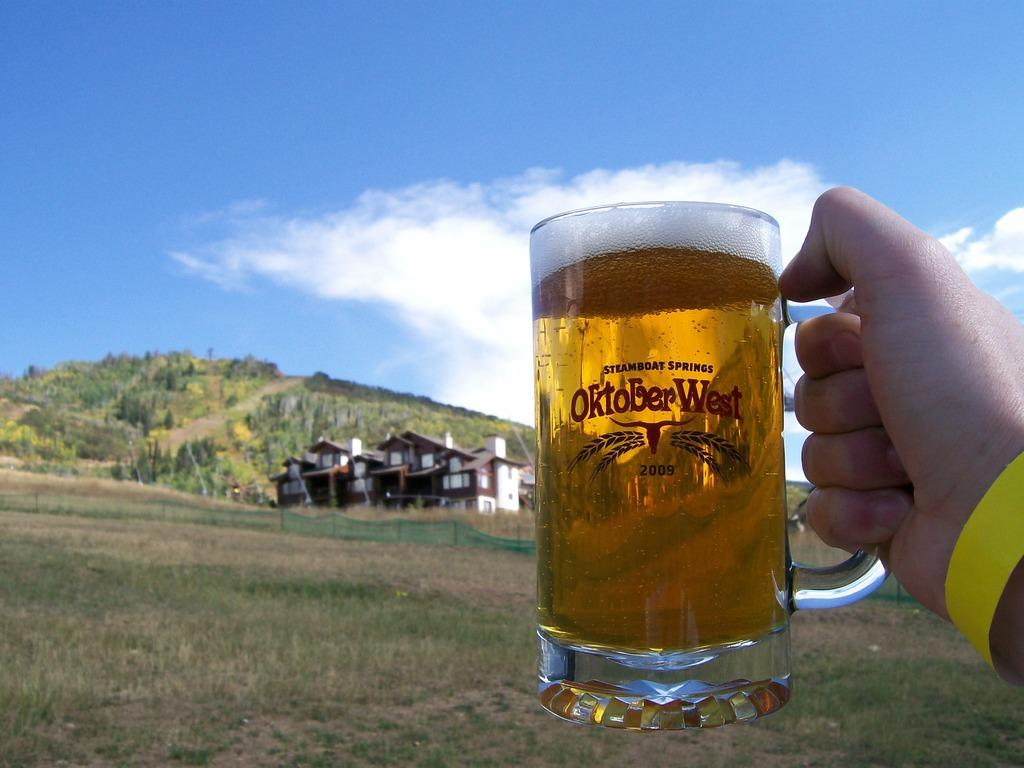<image>
Offer a succinct explanation of the picture presented. Man holding a full beer mug etched with OktoberWest Steamboat Springs 2009 on the surface. 